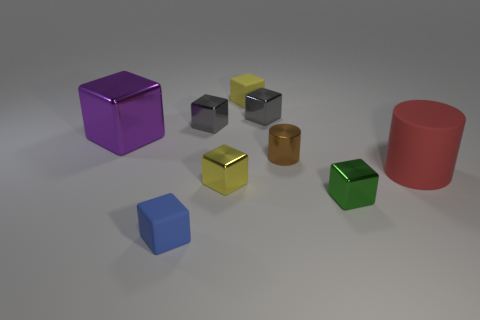How many small brown shiny objects have the same shape as the blue object?
Your response must be concise. 0. Are there fewer small matte cubes to the right of the large red cylinder than small things behind the small brown cylinder?
Make the answer very short. Yes. How many tiny blue matte blocks are to the left of the small object in front of the small green shiny cube?
Your answer should be very brief. 0. Are any large purple matte blocks visible?
Your response must be concise. No. Are there any big things that have the same material as the red cylinder?
Give a very brief answer. No. Are there more tiny yellow matte things in front of the tiny brown shiny object than tiny metal cylinders to the right of the large matte thing?
Your answer should be compact. No. Do the green metallic object and the red matte cylinder have the same size?
Provide a succinct answer. No. What is the color of the matte cube behind the object that is to the left of the tiny blue matte object?
Your answer should be very brief. Yellow. What is the color of the big cylinder?
Your answer should be very brief. Red. How many objects are cubes left of the brown cylinder or small blue spheres?
Provide a succinct answer. 6. 